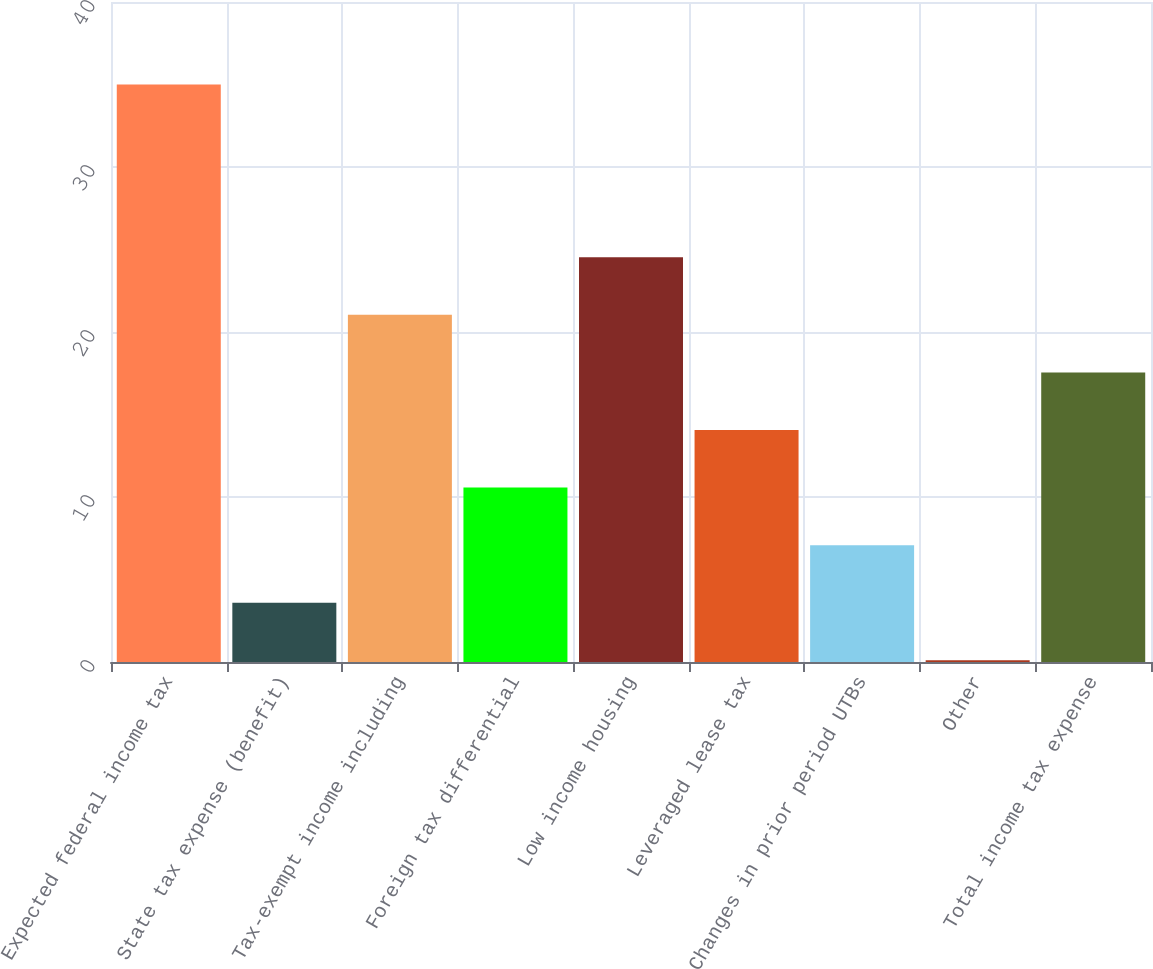<chart> <loc_0><loc_0><loc_500><loc_500><bar_chart><fcel>Expected federal income tax<fcel>State tax expense (benefit)<fcel>Tax-exempt income including<fcel>Foreign tax differential<fcel>Low income housing<fcel>Leveraged lease tax<fcel>Changes in prior period UTBs<fcel>Other<fcel>Total income tax expense<nl><fcel>35<fcel>3.59<fcel>21.04<fcel>10.57<fcel>24.53<fcel>14.06<fcel>7.08<fcel>0.1<fcel>17.55<nl></chart> 